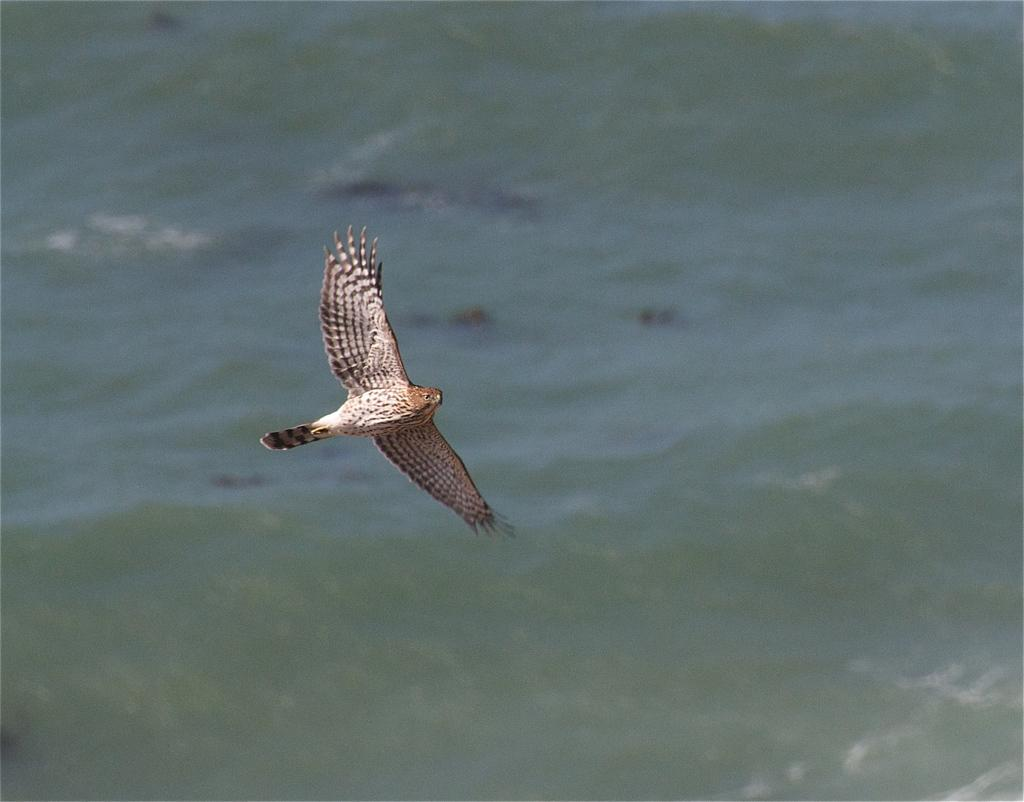What is the main subject of the image? The main subject of the image is a bird flying in the air. What can be seen in the background of the image? The background of the image is an ocean. What type of line can be seen in the image? There is no line present in the image; it features a bird flying in the air against an ocean background. Can you tell me how many kittens are swimming in the ocean in the image? There are no kittens present in the image; it features a bird flying in the air against an ocean background. 